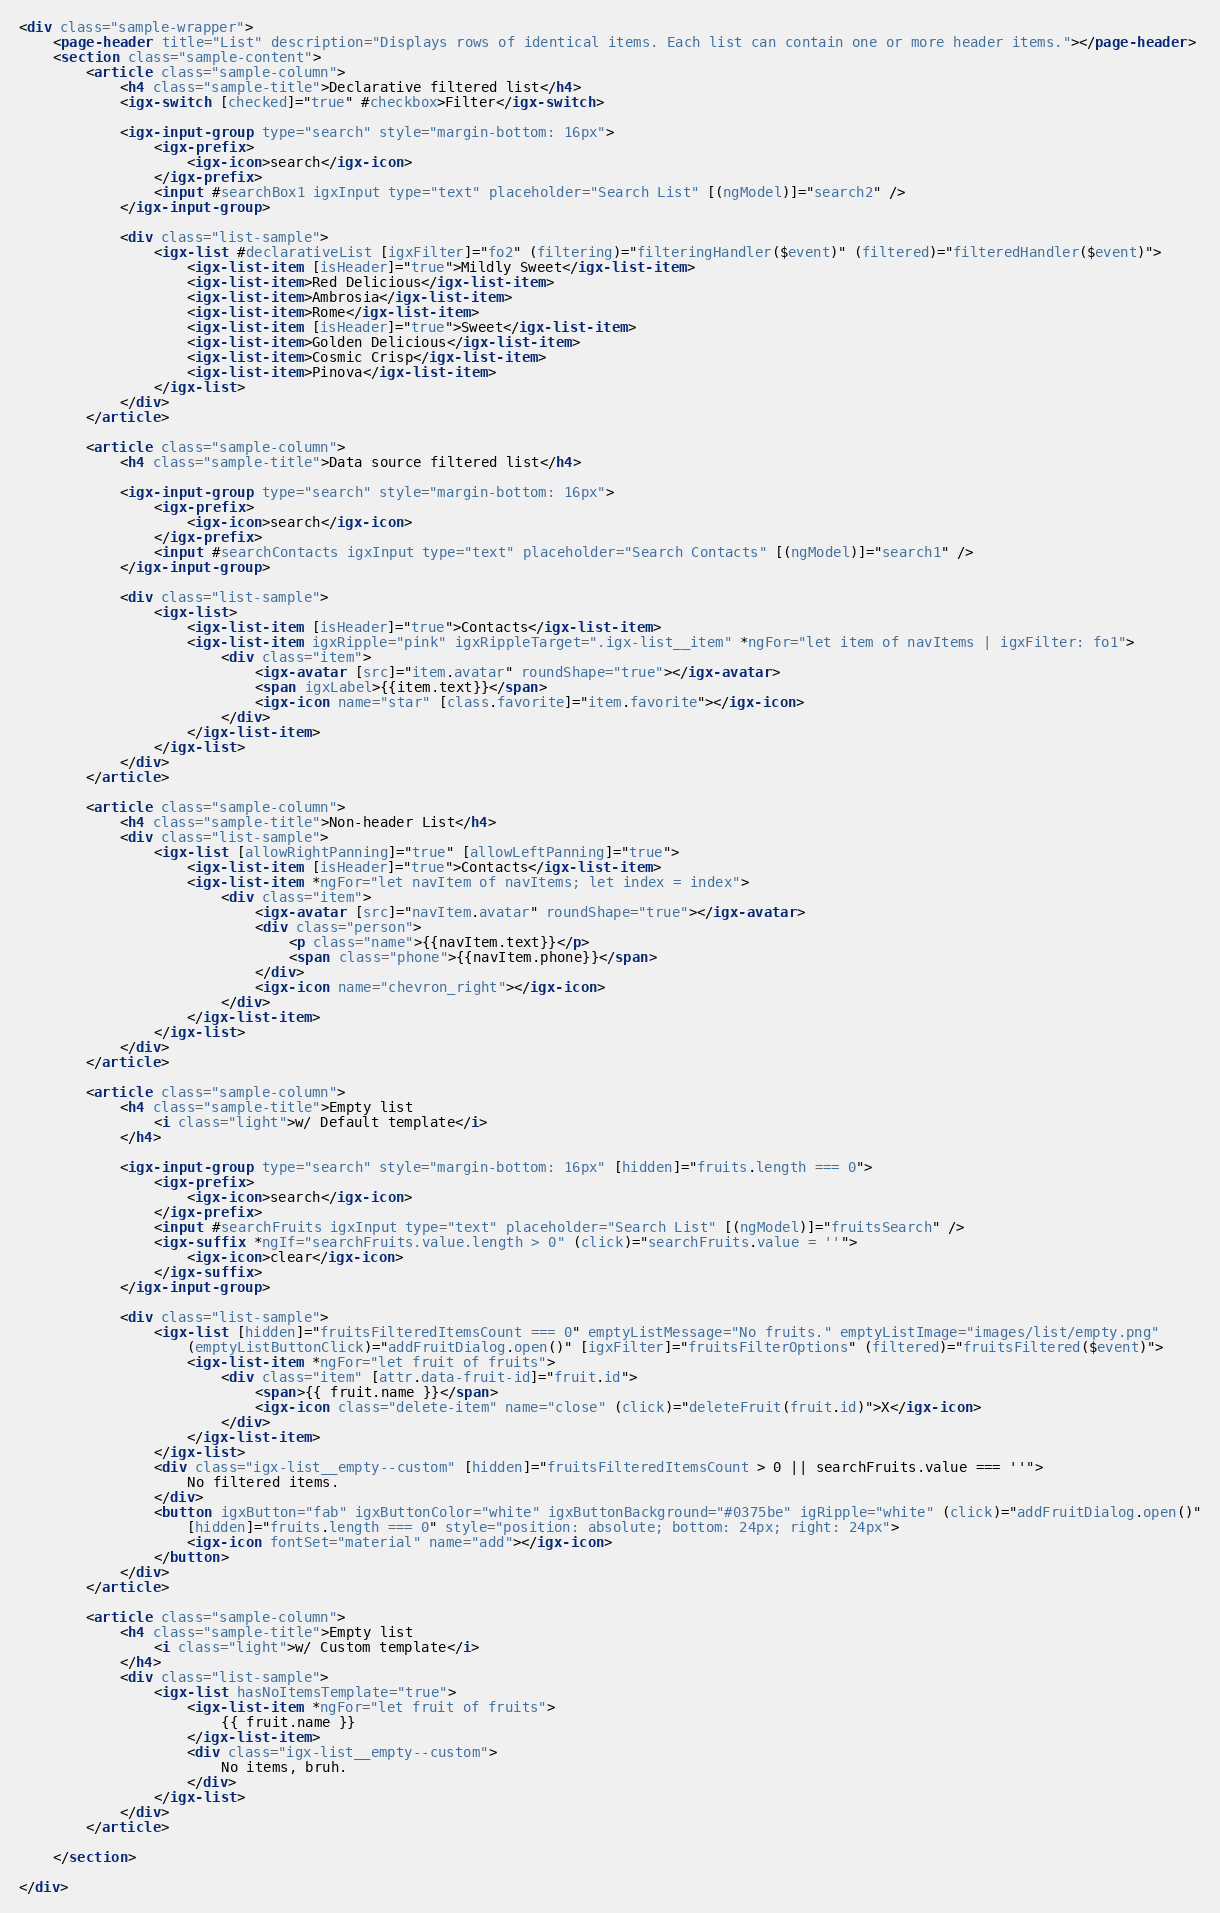Convert code to text. <code><loc_0><loc_0><loc_500><loc_500><_HTML_><div class="sample-wrapper">
    <page-header title="List" description="Displays rows of identical items. Each list can contain one or more header items."></page-header>
    <section class="sample-content">
        <article class="sample-column">
            <h4 class="sample-title">Declarative filtered list</h4>
            <igx-switch [checked]="true" #checkbox>Filter</igx-switch>

            <igx-input-group type="search" style="margin-bottom: 16px">
                <igx-prefix>
                    <igx-icon>search</igx-icon>
                </igx-prefix>
                <input #searchBox1 igxInput type="text" placeholder="Search List" [(ngModel)]="search2" />
            </igx-input-group>

            <div class="list-sample">
                <igx-list #declarativeList [igxFilter]="fo2" (filtering)="filteringHandler($event)" (filtered)="filteredHandler($event)">
                    <igx-list-item [isHeader]="true">Mildly Sweet</igx-list-item>
                    <igx-list-item>Red Delicious</igx-list-item>
                    <igx-list-item>Ambrosia</igx-list-item>
                    <igx-list-item>Rome</igx-list-item>
                    <igx-list-item [isHeader]="true">Sweet</igx-list-item>
                    <igx-list-item>Golden Delicious</igx-list-item>
                    <igx-list-item>Cosmic Crisp</igx-list-item>
                    <igx-list-item>Pinova</igx-list-item>
                </igx-list>
            </div>
        </article>

        <article class="sample-column">
            <h4 class="sample-title">Data source filtered list</h4>

            <igx-input-group type="search" style="margin-bottom: 16px">
                <igx-prefix>
                    <igx-icon>search</igx-icon>
                </igx-prefix>
                <input #searchContacts igxInput type="text" placeholder="Search Contacts" [(ngModel)]="search1" />
            </igx-input-group>

            <div class="list-sample">
                <igx-list>
                    <igx-list-item [isHeader]="true">Contacts</igx-list-item>
                    <igx-list-item igxRipple="pink" igxRippleTarget=".igx-list__item" *ngFor="let item of navItems | igxFilter: fo1">
                        <div class="item">
                            <igx-avatar [src]="item.avatar" roundShape="true"></igx-avatar>
                            <span igxLabel>{{item.text}}</span>
                            <igx-icon name="star" [class.favorite]="item.favorite"></igx-icon>
                        </div>
                    </igx-list-item>
                </igx-list>
            </div>
        </article>

        <article class="sample-column">
            <h4 class="sample-title">Non-header List</h4>
            <div class="list-sample">
                <igx-list [allowRightPanning]="true" [allowLeftPanning]="true">
                    <igx-list-item [isHeader]="true">Contacts</igx-list-item>
                    <igx-list-item *ngFor="let navItem of navItems; let index = index">
                        <div class="item">
                            <igx-avatar [src]="navItem.avatar" roundShape="true"></igx-avatar>
                            <div class="person">
                                <p class="name">{{navItem.text}}</p>
                                <span class="phone">{{navItem.phone}}</span>
                            </div>
                            <igx-icon name="chevron_right"></igx-icon>
                        </div>
                    </igx-list-item>
                </igx-list>
            </div>
        </article>

        <article class="sample-column">
            <h4 class="sample-title">Empty list
                <i class="light">w/ Default template</i>
            </h4>

            <igx-input-group type="search" style="margin-bottom: 16px" [hidden]="fruits.length === 0">
                <igx-prefix>
                    <igx-icon>search</igx-icon>
                </igx-prefix>
                <input #searchFruits igxInput type="text" placeholder="Search List" [(ngModel)]="fruitsSearch" />
                <igx-suffix *ngIf="searchFruits.value.length > 0" (click)="searchFruits.value = ''">
                    <igx-icon>clear</igx-icon>
                </igx-suffix>
            </igx-input-group>

            <div class="list-sample">
                <igx-list [hidden]="fruitsFilteredItemsCount === 0" emptyListMessage="No fruits." emptyListImage="images/list/empty.png"
                    (emptyListButtonClick)="addFruitDialog.open()" [igxFilter]="fruitsFilterOptions" (filtered)="fruitsFiltered($event)">
                    <igx-list-item *ngFor="let fruit of fruits">
                        <div class="item" [attr.data-fruit-id]="fruit.id">
                            <span>{{ fruit.name }}</span>
                            <igx-icon class="delete-item" name="close" (click)="deleteFruit(fruit.id)">X</igx-icon>
                        </div>
                    </igx-list-item>
                </igx-list>
                <div class="igx-list__empty--custom" [hidden]="fruitsFilteredItemsCount > 0 || searchFruits.value === ''">
                    No filtered items.
                </div>
                <button igxButton="fab" igxButtonColor="white" igxButtonBackground="#0375be" igRipple="white" (click)="addFruitDialog.open()"
                    [hidden]="fruits.length === 0" style="position: absolute; bottom: 24px; right: 24px">
                    <igx-icon fontSet="material" name="add"></igx-icon>
                </button>
            </div>
        </article>

        <article class="sample-column">
            <h4 class="sample-title">Empty list
                <i class="light">w/ Custom template</i>
            </h4>
            <div class="list-sample">
                <igx-list hasNoItemsTemplate="true">
                    <igx-list-item *ngFor="let fruit of fruits">
                        {{ fruit.name }}
                    </igx-list-item>
                    <div class="igx-list__empty--custom">
                        No items, bruh.
                    </div>
                </igx-list>
            </div>
        </article>

    </section>

</div>
</code> 